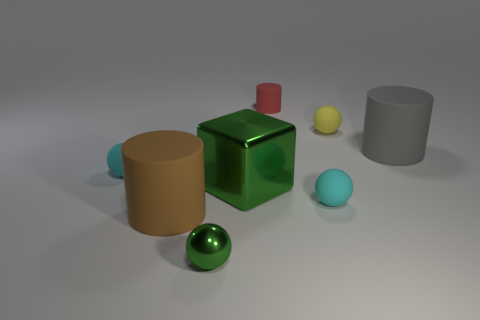Add 1 tiny cyan shiny balls. How many objects exist? 9 Subtract 0 red cubes. How many objects are left? 8 Subtract all cylinders. How many objects are left? 5 Subtract 1 spheres. How many spheres are left? 3 Subtract all brown cylinders. Subtract all brown spheres. How many cylinders are left? 2 Subtract all cyan spheres. How many purple cylinders are left? 0 Subtract all large red objects. Subtract all tiny cylinders. How many objects are left? 7 Add 3 brown things. How many brown things are left? 4 Add 8 big green shiny things. How many big green shiny things exist? 9 Subtract all gray cylinders. How many cylinders are left? 2 